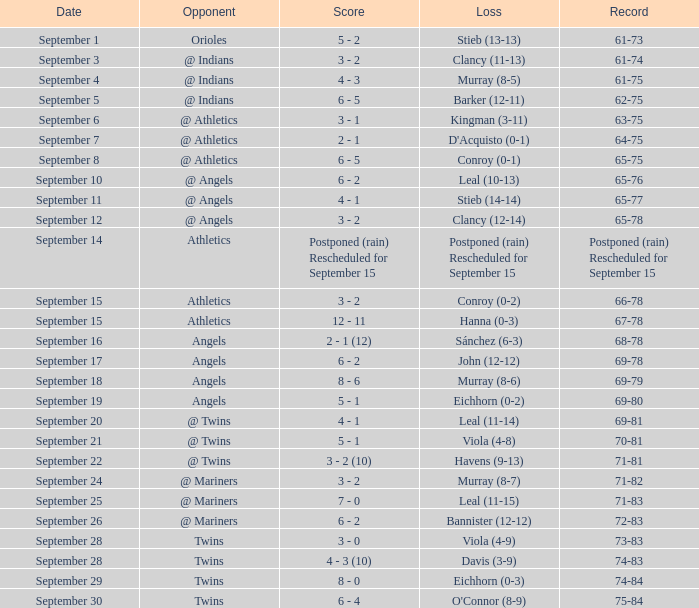Name the score which has record of 73-83 3 - 0. 